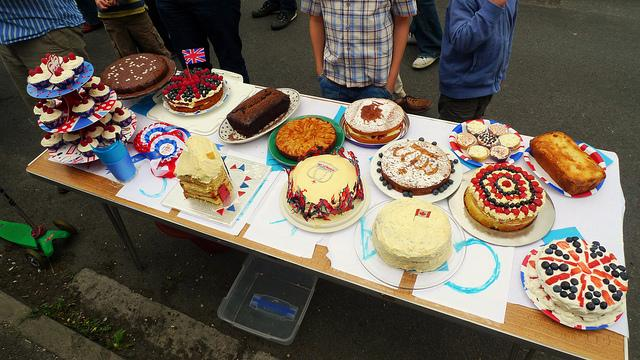The flag of what country is placed in the berry cake? Please explain your reasoning. united kingdom. The cake has a british flag on it. 